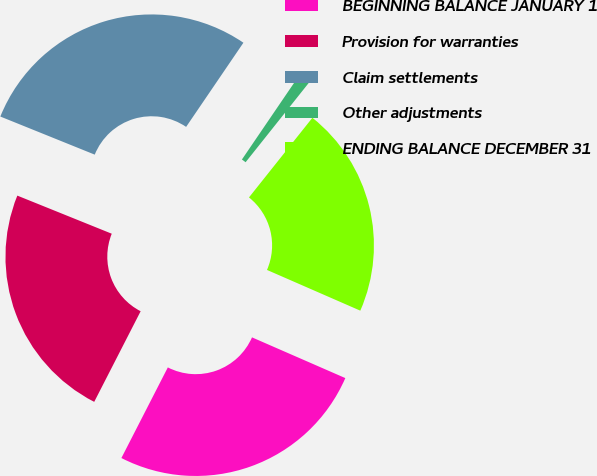<chart> <loc_0><loc_0><loc_500><loc_500><pie_chart><fcel>BEGINNING BALANCE JANUARY 1<fcel>Provision for warranties<fcel>Claim settlements<fcel>Other adjustments<fcel>ENDING BALANCE DECEMBER 31<nl><fcel>25.99%<fcel>23.57%<fcel>28.41%<fcel>1.19%<fcel>20.85%<nl></chart> 